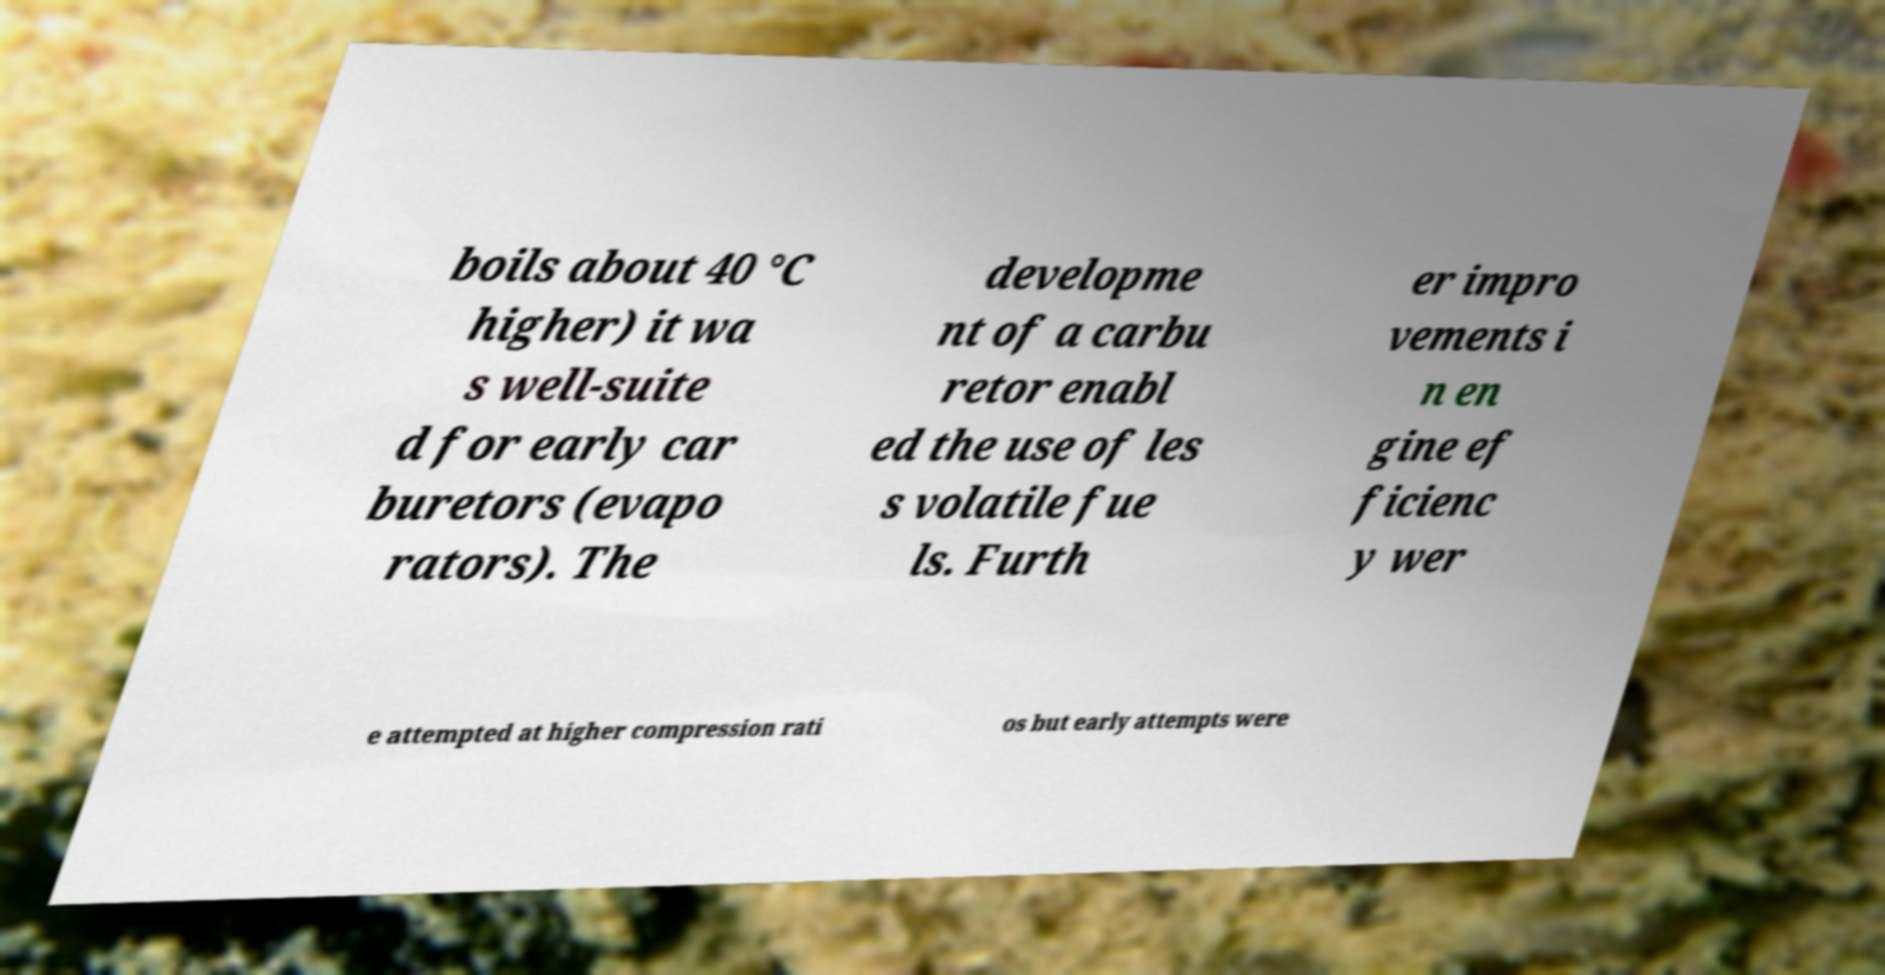I need the written content from this picture converted into text. Can you do that? boils about 40 °C higher) it wa s well-suite d for early car buretors (evapo rators). The developme nt of a carbu retor enabl ed the use of les s volatile fue ls. Furth er impro vements i n en gine ef ficienc y wer e attempted at higher compression rati os but early attempts were 